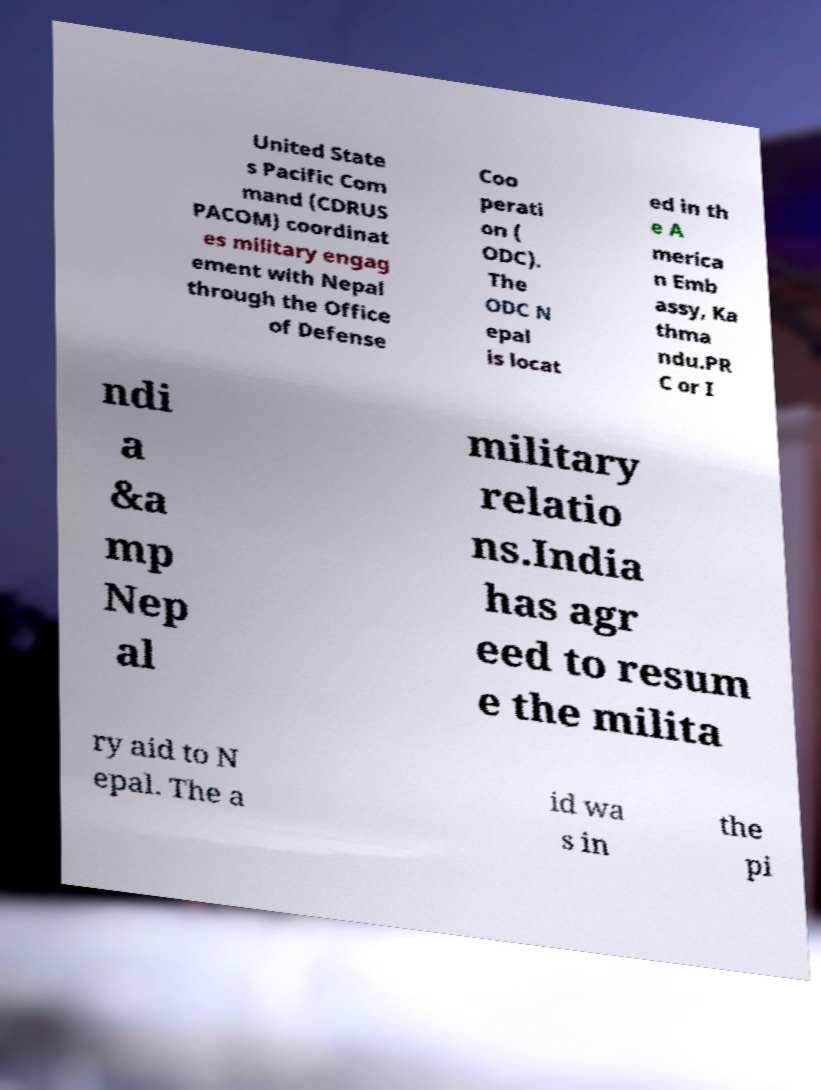I need the written content from this picture converted into text. Can you do that? United State s Pacific Com mand (CDRUS PACOM) coordinat es military engag ement with Nepal through the Office of Defense Coo perati on ( ODC). The ODC N epal is locat ed in th e A merica n Emb assy, Ka thma ndu.PR C or I ndi a &a mp Nep al military relatio ns.India has agr eed to resum e the milita ry aid to N epal. The a id wa s in the pi 